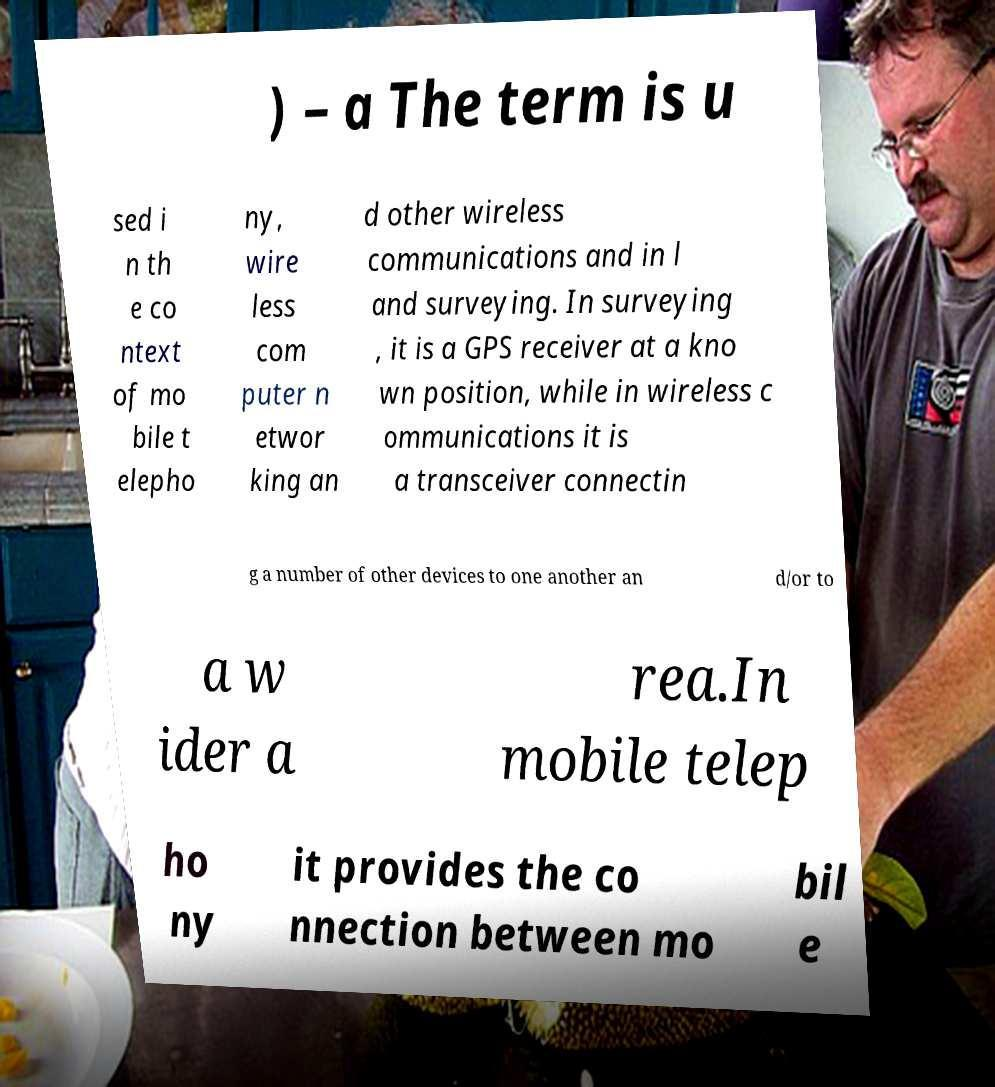For documentation purposes, I need the text within this image transcribed. Could you provide that? ) – a The term is u sed i n th e co ntext of mo bile t elepho ny, wire less com puter n etwor king an d other wireless communications and in l and surveying. In surveying , it is a GPS receiver at a kno wn position, while in wireless c ommunications it is a transceiver connectin g a number of other devices to one another an d/or to a w ider a rea.In mobile telep ho ny it provides the co nnection between mo bil e 